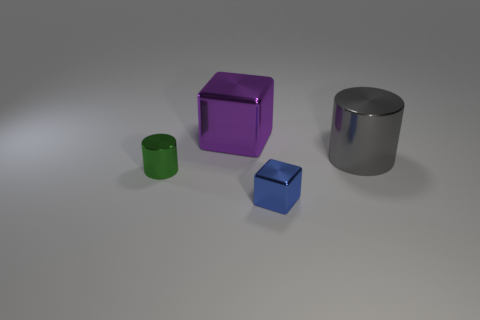The purple metallic thing that is the same shape as the small blue object is what size?
Make the answer very short. Large. Are there an equal number of green shiny objects and large brown things?
Offer a terse response. No. What number of blue things are behind the tiny shiny cube?
Your answer should be very brief. 0. What is the color of the tiny shiny object right of the metal block that is left of the blue thing?
Provide a succinct answer. Blue. Is there anything else that is the same shape as the big purple shiny object?
Keep it short and to the point. Yes. Are there the same number of big objects that are in front of the big gray cylinder and small green metallic objects that are behind the small blue shiny thing?
Offer a terse response. No. What number of cylinders are yellow objects or purple metal objects?
Your response must be concise. 0. What number of other objects are there of the same material as the big cylinder?
Give a very brief answer. 3. What is the shape of the large metal thing that is left of the gray shiny object?
Ensure brevity in your answer.  Cube. What material is the small object behind the metal cube that is in front of the big gray metal cylinder made of?
Your answer should be very brief. Metal. 